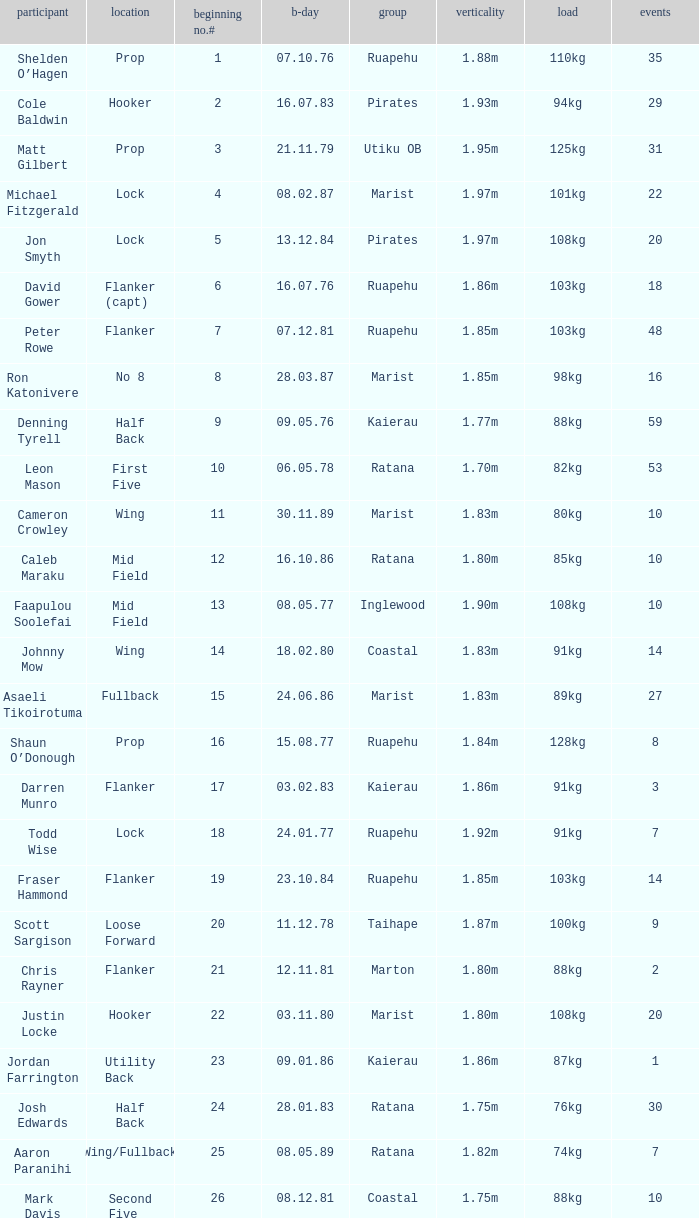How many games were played where the height of the player is 1.92m? 1.0. 